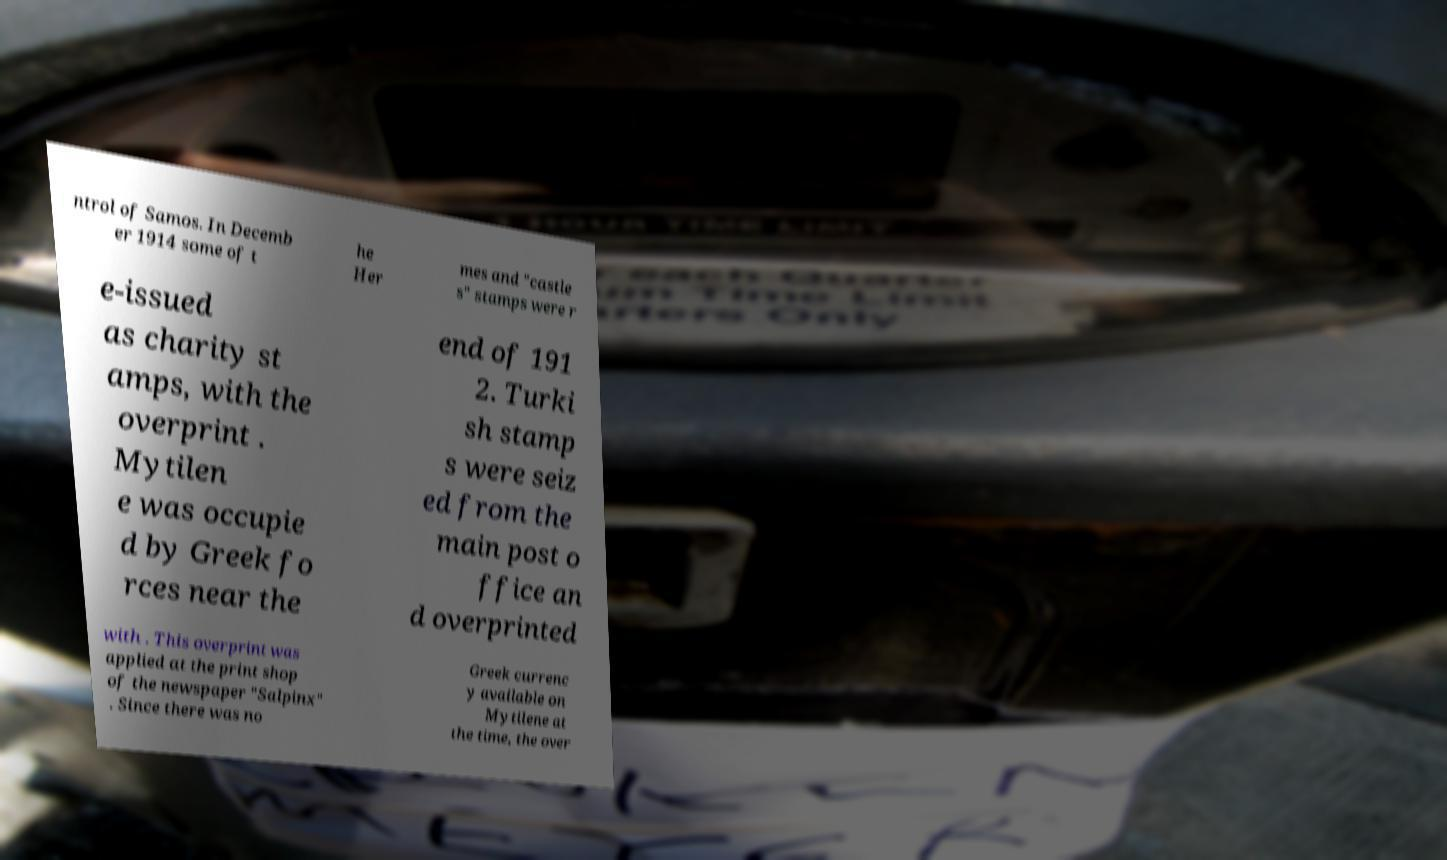Can you read and provide the text displayed in the image?This photo seems to have some interesting text. Can you extract and type it out for me? ntrol of Samos. In Decemb er 1914 some of t he Her mes and "castle s" stamps were r e-issued as charity st amps, with the overprint . Mytilen e was occupie d by Greek fo rces near the end of 191 2. Turki sh stamp s were seiz ed from the main post o ffice an d overprinted with . This overprint was applied at the print shop of the newspaper "Salpinx" . Since there was no Greek currenc y available on Mytilene at the time, the over 